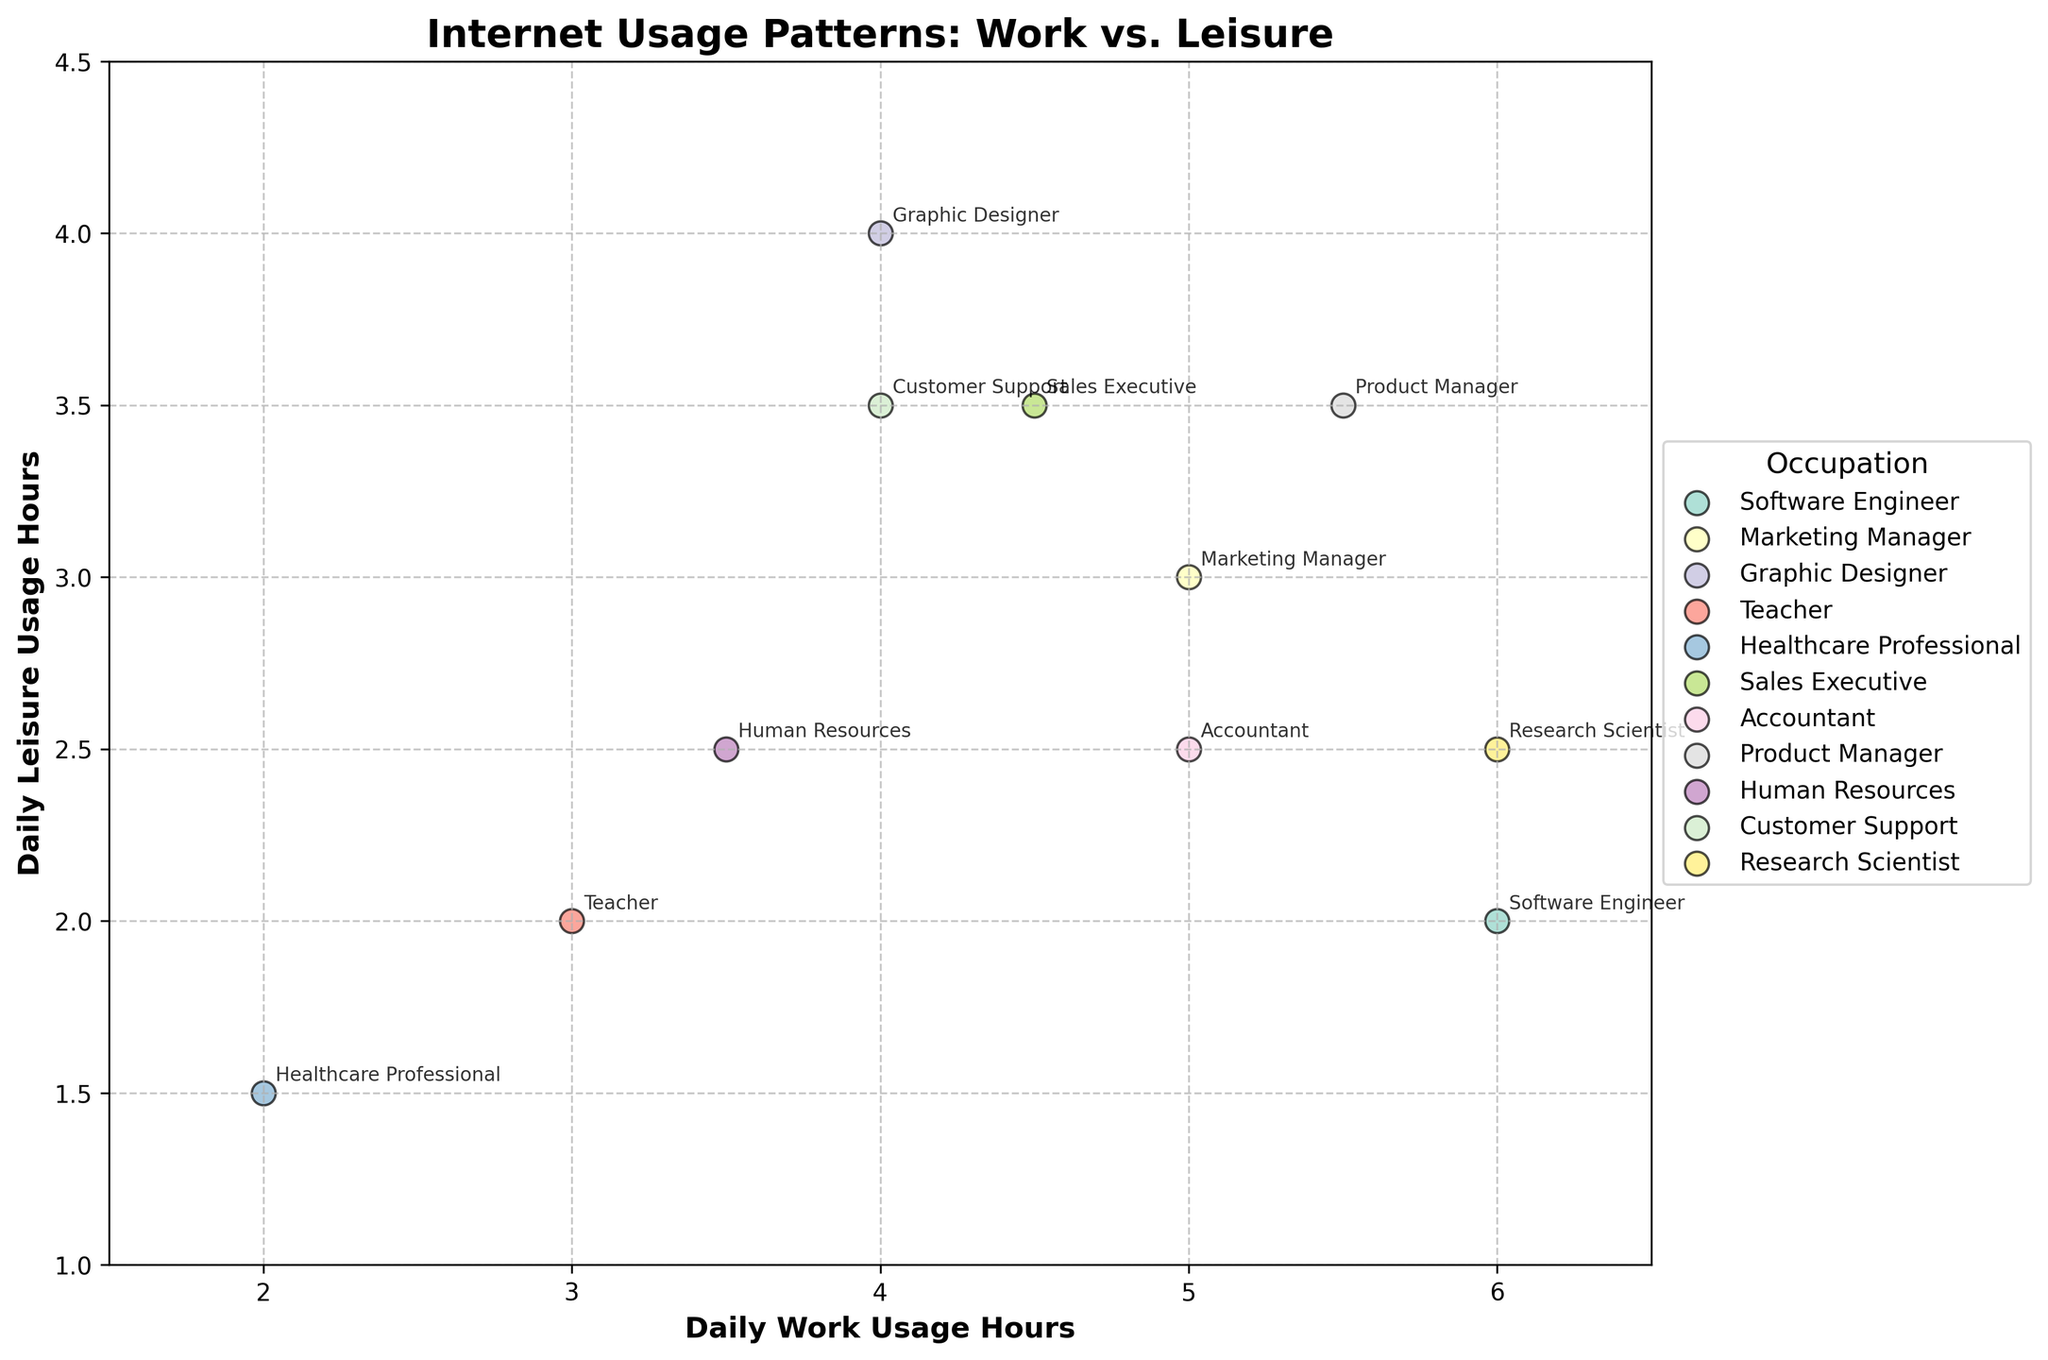What's the average daily work usage hours across all occupations? Sum the daily work usage hours for all occupations (6 + 5 + 4 + 3 + 2 + 4.5 + 5 + 5.5 + 3.5 + 4 + 6 = 48.5) and divide by the number of occupations (11). The average is 48.5 / 11.
Answer: 4.41 Which occupation has the highest daily leisure usage hours? Compare the leisure hours across all occupations. Graphic Designer has the highest leisure usage hours (4 hours).
Answer: Graphic Designer What is the difference in work usage hours between a Software Engineer and a Healthcare Professional? Subtract the work hours of a Healthcare Professional (2) from a Software Engineer (6). The difference is 6 - 2.
Answer: 4 Are there any occupations with equal daily hours for work and leisure activities? Examine each data point to find occupations where daily work and leisure hours are equal. Only Graphic Designer has equal daily usage hours (4 hours each).
Answer: Yes, Graphic Designer Which two occupations are closest in daily leisure usage hours? Compare the daily leisure usage hours of each occupation. Marketing Manager (3) and Customer Support (3.5) are closest. The difference is 0.5 hours.
Answer: Marketing Manager and Customer Support Which occupation has the lowest combined daily usage hours for work and leisure? Add the work and leisure hours for each occupation and find the lowest sum. Healthcare Professional has the lowest combined hours (2 + 1.5 = 3.5).
Answer: Healthcare Professional What is the standard deviation of the work usage hours data? First, find the mean (4.41), then calculate the squared differences from the mean for each value, average these squared differences, and finally take the square root of this average to get the standard deviation.
Answer: 1.19 How do the daily leisure usage hours for Product Manager compare to Accountant? Product Manager has 3.5 leisure hours and Accountant has 2.5 leisure hours. Product Manager has 1 more hour of leisure usage.
Answer: Product Manager has 1 more hour What's the range of daily work usage hours across all occupations? Range is the difference between the maximum and minimum work hours. Max is 6 (Software Engineer, Research Scientist), Min is 2 (Healthcare Professional). The range is 6 - 2.
Answer: 4 Which occupation has the greatest differential between work and leisure usage hours? For each occupation, calculate the absolute difference between work and leisure hours. Software Engineer has the greatest differential (6 - 2 = 4 hours).
Answer: Software Engineer 